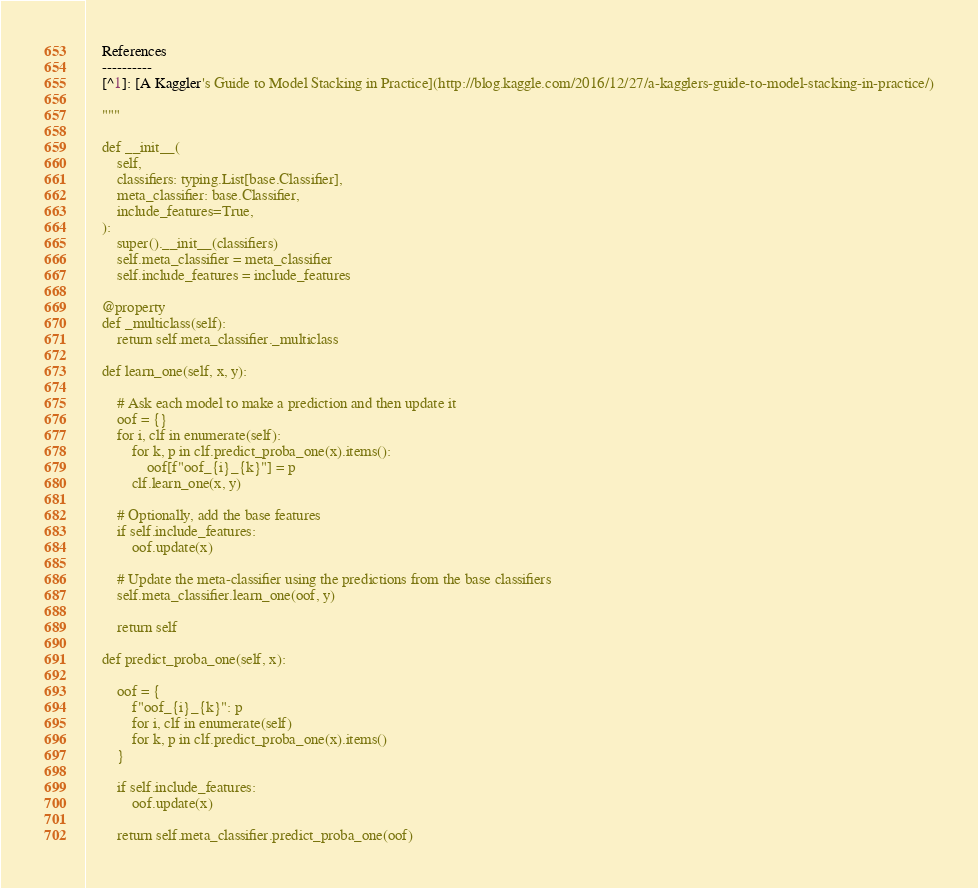<code> <loc_0><loc_0><loc_500><loc_500><_Python_>
    References
    ----------
    [^1]: [A Kaggler's Guide to Model Stacking in Practice](http://blog.kaggle.com/2016/12/27/a-kagglers-guide-to-model-stacking-in-practice/)

    """

    def __init__(
        self,
        classifiers: typing.List[base.Classifier],
        meta_classifier: base.Classifier,
        include_features=True,
    ):
        super().__init__(classifiers)
        self.meta_classifier = meta_classifier
        self.include_features = include_features

    @property
    def _multiclass(self):
        return self.meta_classifier._multiclass

    def learn_one(self, x, y):

        # Ask each model to make a prediction and then update it
        oof = {}
        for i, clf in enumerate(self):
            for k, p in clf.predict_proba_one(x).items():
                oof[f"oof_{i}_{k}"] = p
            clf.learn_one(x, y)

        # Optionally, add the base features
        if self.include_features:
            oof.update(x)

        # Update the meta-classifier using the predictions from the base classifiers
        self.meta_classifier.learn_one(oof, y)

        return self

    def predict_proba_one(self, x):

        oof = {
            f"oof_{i}_{k}": p
            for i, clf in enumerate(self)
            for k, p in clf.predict_proba_one(x).items()
        }

        if self.include_features:
            oof.update(x)

        return self.meta_classifier.predict_proba_one(oof)
</code> 